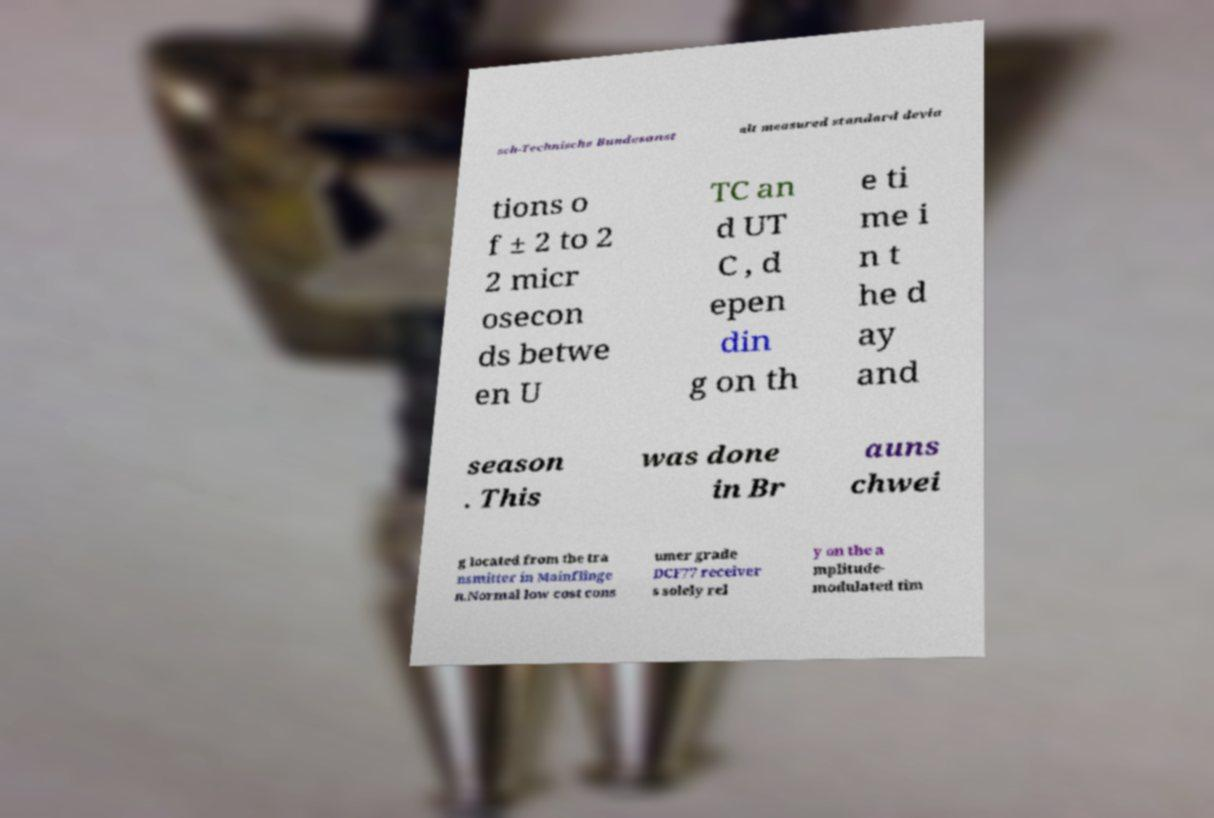Can you read and provide the text displayed in the image?This photo seems to have some interesting text. Can you extract and type it out for me? sch-Technische Bundesanst alt measured standard devia tions o f ± 2 to 2 2 micr osecon ds betwe en U TC an d UT C , d epen din g on th e ti me i n t he d ay and season . This was done in Br auns chwei g located from the tra nsmitter in Mainflinge n.Normal low cost cons umer grade DCF77 receiver s solely rel y on the a mplitude- modulated tim 